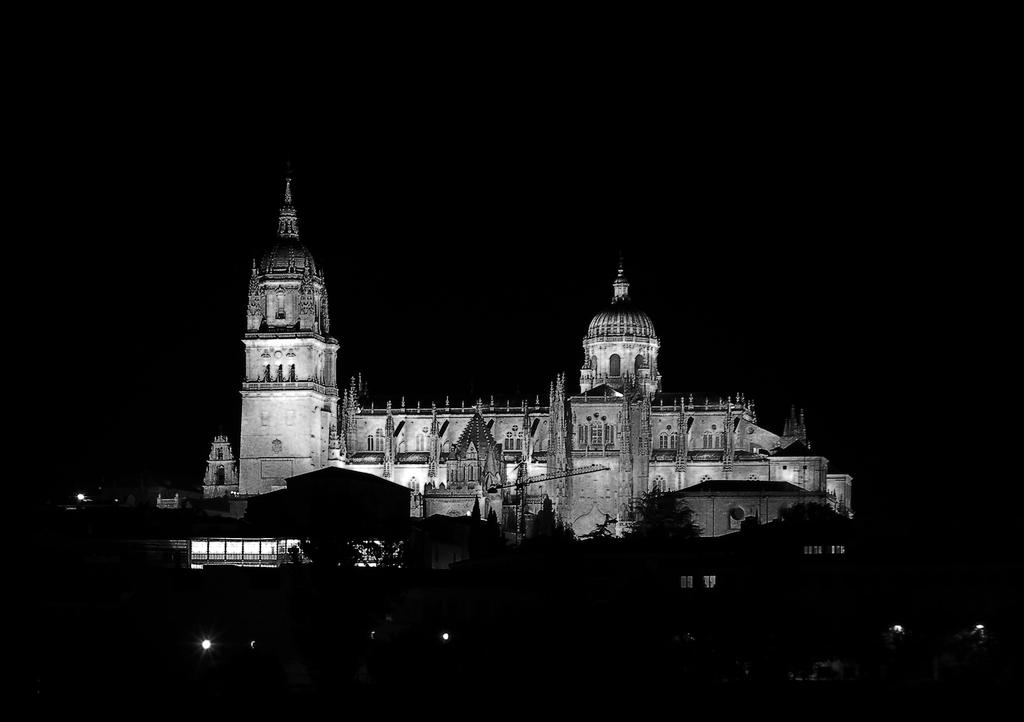What type of structure is present in the image? There is a building in the image. What type of natural vegetation is visible in the image? There are trees in the image. What type of artificial light sources are present in the image? There are lights in the image. What is the color of the background in the image? The background of the image is dark. Can you tell me how many firemen are visible in the image? There are no firemen present in the image. What type of stretch is being used by the plant in the image? There is no stretch or plant present in the image. 